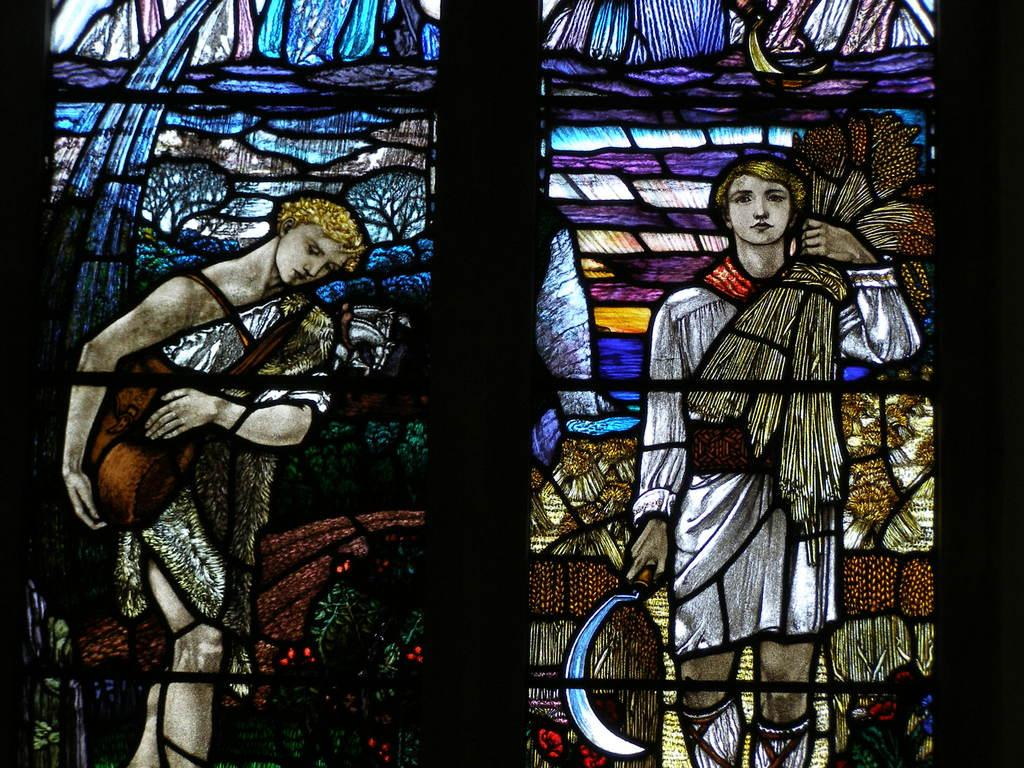What type of window is depicted in the image? There is a glass window in the image. Does the glass window have any unique features? Yes, the glass window has a design on it. What is the subject of the design on the glass window? The design features a girl. What is the girl holding in her hand? The girl is holding dry grass in her hand. On which side of the design is the girl located? The girl is on the right side of the design. How would you classify the image? The image appears to be a form of art. What type of meat is being prepared by the girl in the image? There is no meat or any indication of food preparation in the image. The girl is holding dry grass in her hand, not meat. 